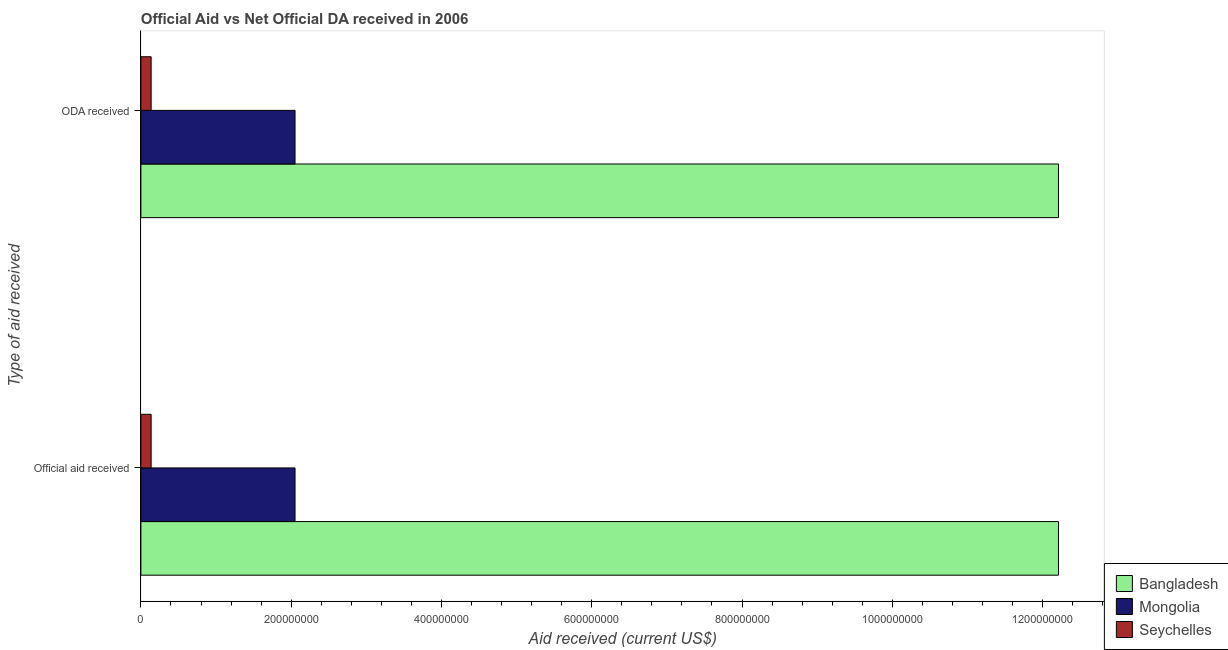How many different coloured bars are there?
Provide a succinct answer. 3. How many groups of bars are there?
Your answer should be very brief. 2. Are the number of bars on each tick of the Y-axis equal?
Ensure brevity in your answer.  Yes. How many bars are there on the 1st tick from the bottom?
Keep it short and to the point. 3. What is the label of the 1st group of bars from the top?
Give a very brief answer. ODA received. What is the official aid received in Bangladesh?
Ensure brevity in your answer.  1.22e+09. Across all countries, what is the maximum official aid received?
Ensure brevity in your answer.  1.22e+09. Across all countries, what is the minimum oda received?
Your answer should be very brief. 1.36e+07. In which country was the oda received maximum?
Provide a short and direct response. Bangladesh. In which country was the official aid received minimum?
Make the answer very short. Seychelles. What is the total oda received in the graph?
Make the answer very short. 1.44e+09. What is the difference between the oda received in Bangladesh and that in Seychelles?
Give a very brief answer. 1.21e+09. What is the difference between the official aid received in Mongolia and the oda received in Bangladesh?
Provide a short and direct response. -1.02e+09. What is the average official aid received per country?
Provide a short and direct response. 4.80e+08. What is the difference between the oda received and official aid received in Seychelles?
Offer a terse response. 0. What is the ratio of the oda received in Bangladesh to that in Seychelles?
Your answer should be compact. 89.53. What does the 2nd bar from the top in Official aid received represents?
Your answer should be very brief. Mongolia. What does the 2nd bar from the bottom in ODA received represents?
Your answer should be compact. Mongolia. How many bars are there?
Keep it short and to the point. 6. How many countries are there in the graph?
Offer a terse response. 3. Are the values on the major ticks of X-axis written in scientific E-notation?
Provide a short and direct response. No. Does the graph contain grids?
Your answer should be very brief. No. Where does the legend appear in the graph?
Provide a succinct answer. Bottom right. How many legend labels are there?
Your answer should be very brief. 3. What is the title of the graph?
Provide a succinct answer. Official Aid vs Net Official DA received in 2006 . What is the label or title of the X-axis?
Your response must be concise. Aid received (current US$). What is the label or title of the Y-axis?
Offer a very short reply. Type of aid received. What is the Aid received (current US$) in Bangladesh in Official aid received?
Ensure brevity in your answer.  1.22e+09. What is the Aid received (current US$) of Mongolia in Official aid received?
Keep it short and to the point. 2.05e+08. What is the Aid received (current US$) of Seychelles in Official aid received?
Keep it short and to the point. 1.36e+07. What is the Aid received (current US$) in Bangladesh in ODA received?
Offer a very short reply. 1.22e+09. What is the Aid received (current US$) in Mongolia in ODA received?
Give a very brief answer. 2.05e+08. What is the Aid received (current US$) in Seychelles in ODA received?
Provide a succinct answer. 1.36e+07. Across all Type of aid received, what is the maximum Aid received (current US$) of Bangladesh?
Your response must be concise. 1.22e+09. Across all Type of aid received, what is the maximum Aid received (current US$) of Mongolia?
Ensure brevity in your answer.  2.05e+08. Across all Type of aid received, what is the maximum Aid received (current US$) of Seychelles?
Make the answer very short. 1.36e+07. Across all Type of aid received, what is the minimum Aid received (current US$) of Bangladesh?
Ensure brevity in your answer.  1.22e+09. Across all Type of aid received, what is the minimum Aid received (current US$) in Mongolia?
Your answer should be very brief. 2.05e+08. Across all Type of aid received, what is the minimum Aid received (current US$) of Seychelles?
Make the answer very short. 1.36e+07. What is the total Aid received (current US$) in Bangladesh in the graph?
Make the answer very short. 2.44e+09. What is the total Aid received (current US$) in Mongolia in the graph?
Your response must be concise. 4.10e+08. What is the total Aid received (current US$) in Seychelles in the graph?
Provide a succinct answer. 2.73e+07. What is the difference between the Aid received (current US$) in Bangladesh in Official aid received and that in ODA received?
Your response must be concise. 0. What is the difference between the Aid received (current US$) of Mongolia in Official aid received and that in ODA received?
Your answer should be very brief. 0. What is the difference between the Aid received (current US$) in Bangladesh in Official aid received and the Aid received (current US$) in Mongolia in ODA received?
Give a very brief answer. 1.02e+09. What is the difference between the Aid received (current US$) of Bangladesh in Official aid received and the Aid received (current US$) of Seychelles in ODA received?
Keep it short and to the point. 1.21e+09. What is the difference between the Aid received (current US$) in Mongolia in Official aid received and the Aid received (current US$) in Seychelles in ODA received?
Ensure brevity in your answer.  1.92e+08. What is the average Aid received (current US$) in Bangladesh per Type of aid received?
Offer a terse response. 1.22e+09. What is the average Aid received (current US$) in Mongolia per Type of aid received?
Provide a short and direct response. 2.05e+08. What is the average Aid received (current US$) of Seychelles per Type of aid received?
Ensure brevity in your answer.  1.36e+07. What is the difference between the Aid received (current US$) of Bangladesh and Aid received (current US$) of Mongolia in Official aid received?
Provide a succinct answer. 1.02e+09. What is the difference between the Aid received (current US$) in Bangladesh and Aid received (current US$) in Seychelles in Official aid received?
Provide a short and direct response. 1.21e+09. What is the difference between the Aid received (current US$) in Mongolia and Aid received (current US$) in Seychelles in Official aid received?
Offer a terse response. 1.92e+08. What is the difference between the Aid received (current US$) in Bangladesh and Aid received (current US$) in Mongolia in ODA received?
Keep it short and to the point. 1.02e+09. What is the difference between the Aid received (current US$) of Bangladesh and Aid received (current US$) of Seychelles in ODA received?
Your response must be concise. 1.21e+09. What is the difference between the Aid received (current US$) in Mongolia and Aid received (current US$) in Seychelles in ODA received?
Your answer should be very brief. 1.92e+08. What is the ratio of the Aid received (current US$) in Seychelles in Official aid received to that in ODA received?
Keep it short and to the point. 1. What is the difference between the highest and the second highest Aid received (current US$) of Bangladesh?
Your answer should be very brief. 0. What is the difference between the highest and the second highest Aid received (current US$) of Seychelles?
Your answer should be compact. 0. What is the difference between the highest and the lowest Aid received (current US$) of Bangladesh?
Provide a short and direct response. 0. What is the difference between the highest and the lowest Aid received (current US$) in Mongolia?
Provide a short and direct response. 0. 